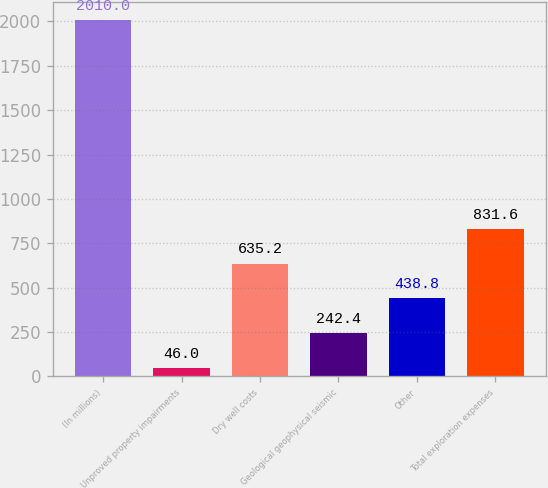<chart> <loc_0><loc_0><loc_500><loc_500><bar_chart><fcel>(In millions)<fcel>Unproved property impairments<fcel>Dry well costs<fcel>Geological geophysical seismic<fcel>Other<fcel>Total exploration expenses<nl><fcel>2010<fcel>46<fcel>635.2<fcel>242.4<fcel>438.8<fcel>831.6<nl></chart> 